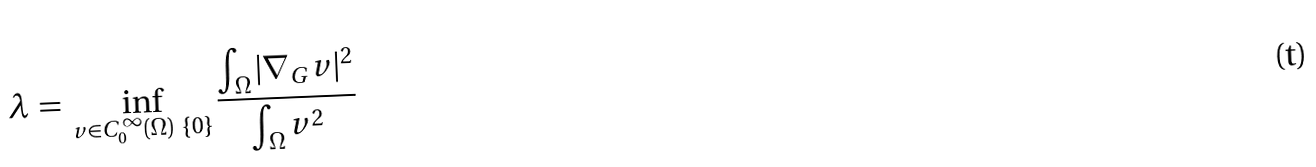Convert formula to latex. <formula><loc_0><loc_0><loc_500><loc_500>\lambda \, = \, \inf _ { v \in C ^ { \infty } _ { 0 } ( \Omega ) \ \{ 0 \} } \frac { \int _ { \Omega } | \nabla _ { G } v | ^ { 2 } } { \int _ { \Omega } v ^ { 2 } }</formula> 